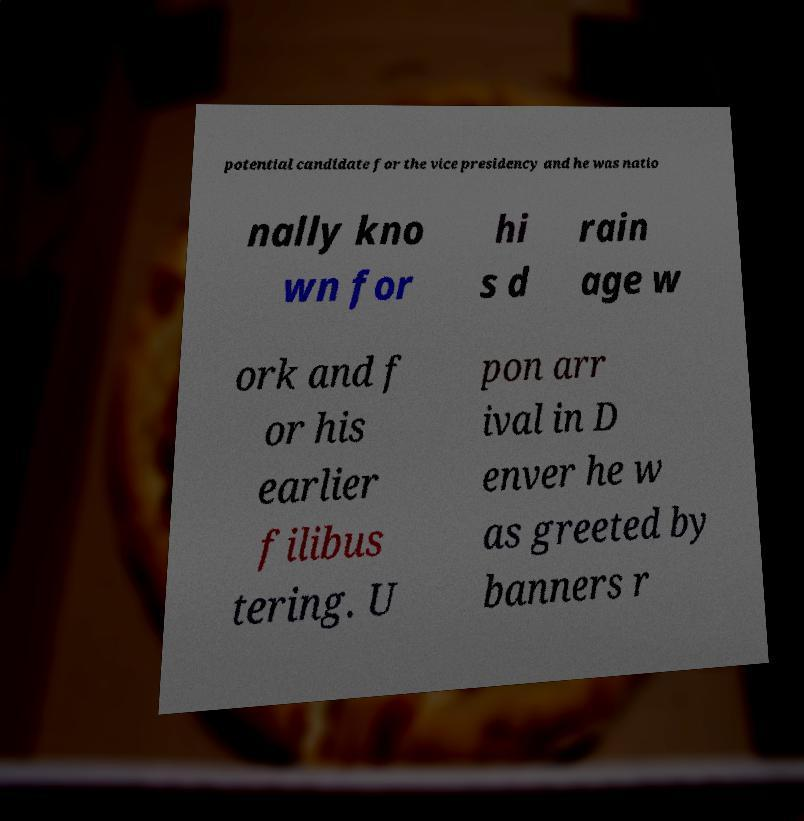Could you extract and type out the text from this image? potential candidate for the vice presidency and he was natio nally kno wn for hi s d rain age w ork and f or his earlier filibus tering. U pon arr ival in D enver he w as greeted by banners r 